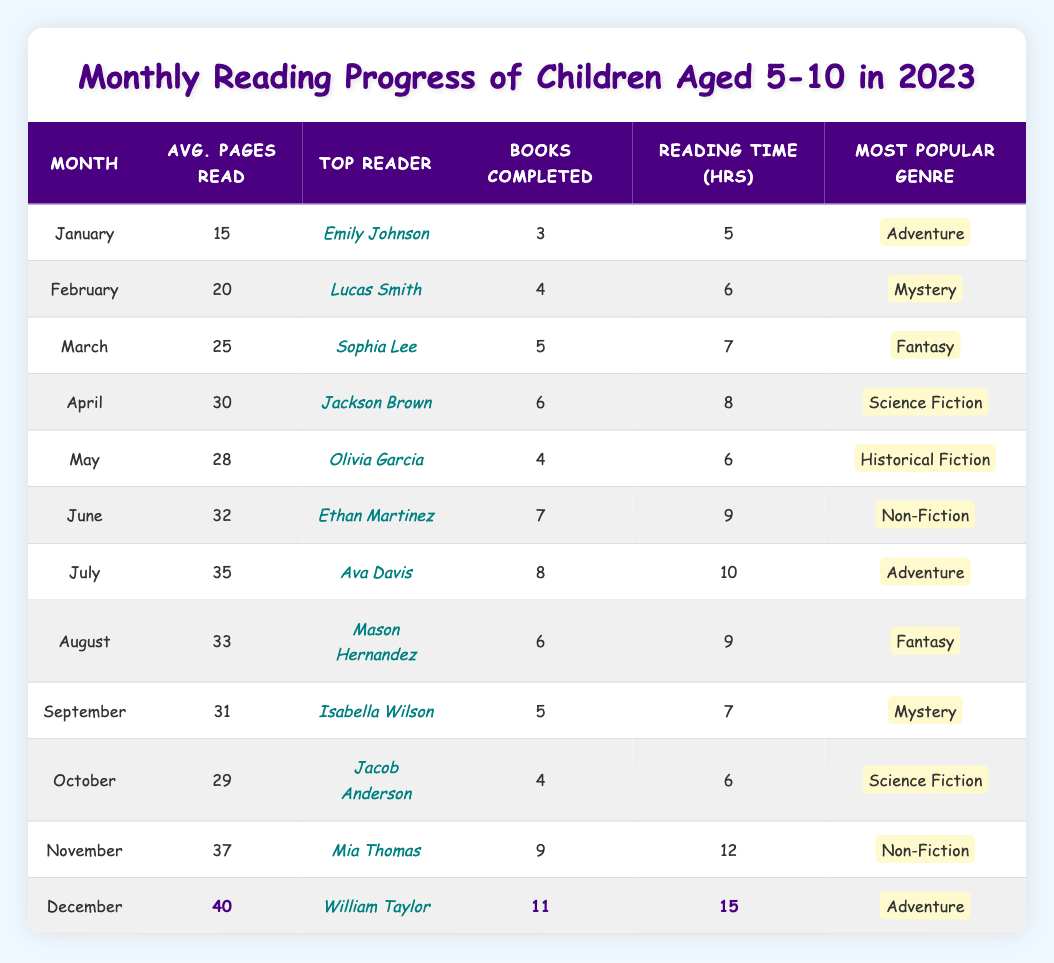What is the top reader for December? In the table, the entry for December lists "William Taylor" as the top reader in the "Top Reader" column.
Answer: William Taylor How many books did Mia Thomas complete in November? The entry for November shows that Mia Thomas completed 9 books, which is stated in the "Books Completed" column.
Answer: 9 What was the average number of pages read in July? For July, the average number of pages read is directly noted in the "Avg. Pages Read" column, which states 35 pages.
Answer: 35 Which month had the highest average pages read? By comparing the values in the "Avg. Pages Read" column, December has the highest value at 40 pages.
Answer: December What is the most popular genre in April? According to the table, the "Most Popular Genre" column for April indicates "Science Fiction."
Answer: Science Fiction How many hours did children read on average in June? The "Reading Time (hrs)" column for June shows that children read for 9 hours on average.
Answer: 9 How many total books were completed from January to November? To find the total, we add up the "Books Completed" column from January (3) to November (9): 3 + 4 + 5 + 6 + 4 + 7 + 8 + 6 + 5 + 4 + 9 = 57.
Answer: 57 Was the average reading time higher in August or September? August has an average reading time of 9 hours, while September has 7 hours according to the "Reading Time (hrs)" column. Thus, August had the higher time.
Answer: August How many more pages were read on average in November compared to January? In November the average is 37 pages, and in January it is 15 pages. The difference is 37 - 15 = 22 pages.
Answer: 22 Who read the most books in the month of December? The table shows that in December, William Taylor was the top reader and he completed 11 books, which is noted in the "Books Completed" column.
Answer: William Taylor What was the average number of pages read in the first half of the year (January to June)? To find this average, we sum the pages read for January (15), February (20), March (25), April (30), May (28), and June (32): 15 + 20 + 25 + 30 + 28 + 32 = 150. Then divide by 6, giving an average of 150 / 6 = 25 pages.
Answer: 25 Which genre was most popular in June? The genre listed for June under "Most Popular Genre" is "Non-Fiction," which can be found in the corresponding column for that month.
Answer: Non-Fiction 